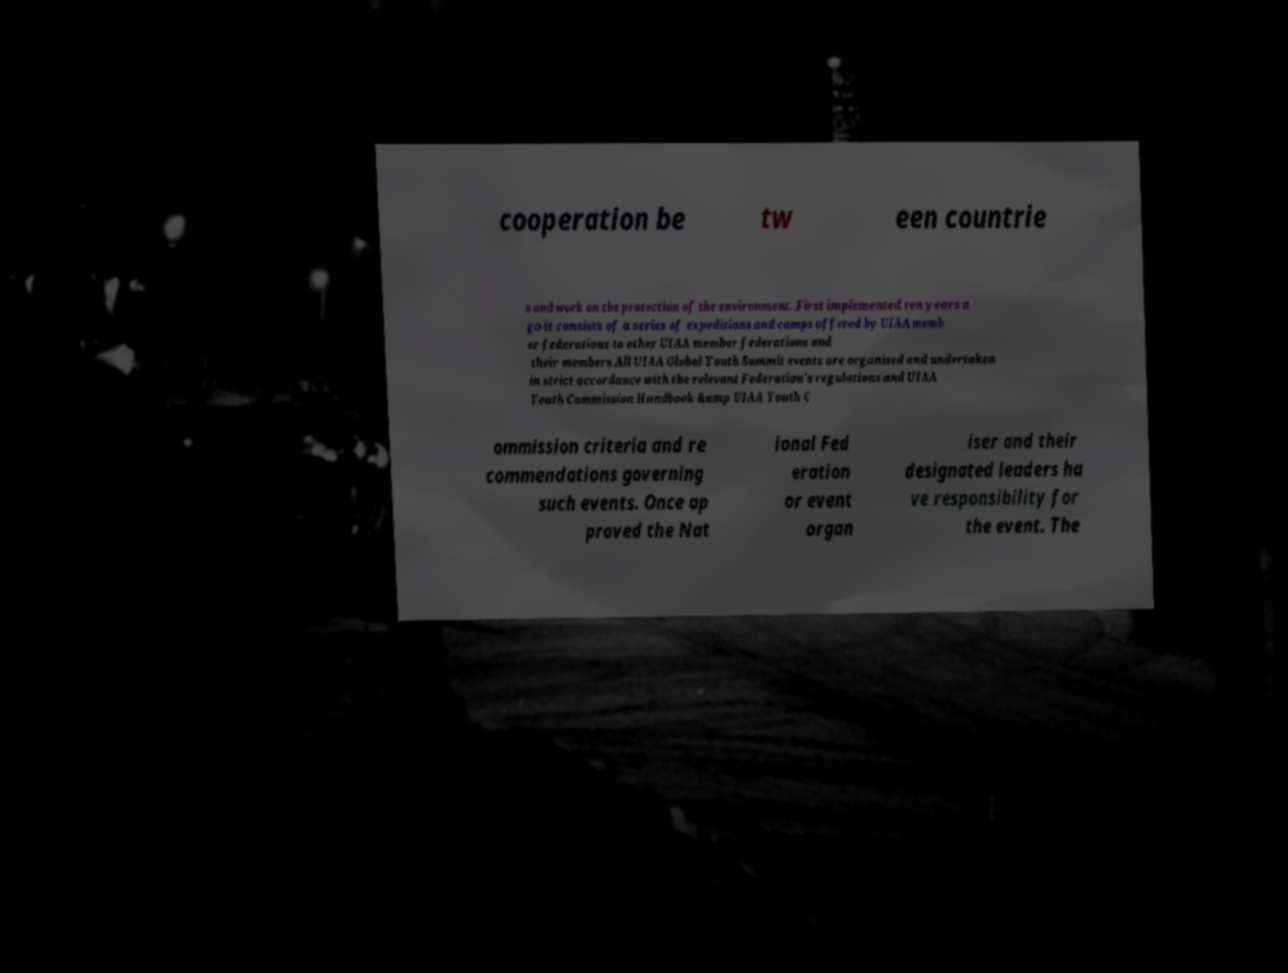Can you accurately transcribe the text from the provided image for me? cooperation be tw een countrie s and work on the protection of the environment. First implemented ten years a go it consists of a series of expeditions and camps offered by UIAA memb er federations to other UIAA member federations and their members.All UIAA Global Youth Summit events are organised and undertaken in strict accordance with the relevant Federation's regulations and UIAA Youth Commission Handbook &amp UIAA Youth C ommission criteria and re commendations governing such events. Once ap proved the Nat ional Fed eration or event organ iser and their designated leaders ha ve responsibility for the event. The 